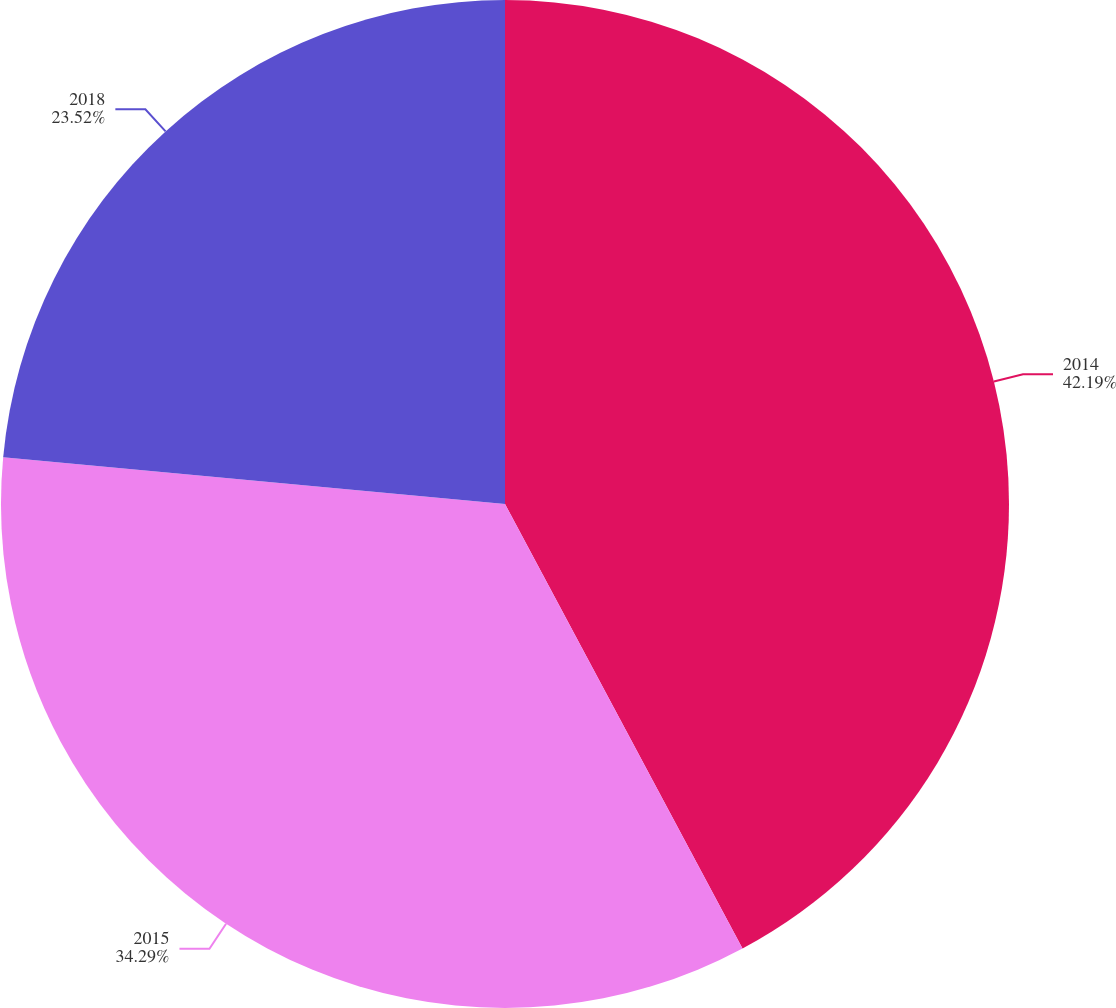<chart> <loc_0><loc_0><loc_500><loc_500><pie_chart><fcel>2014<fcel>2015<fcel>2018<nl><fcel>42.19%<fcel>34.29%<fcel>23.52%<nl></chart> 